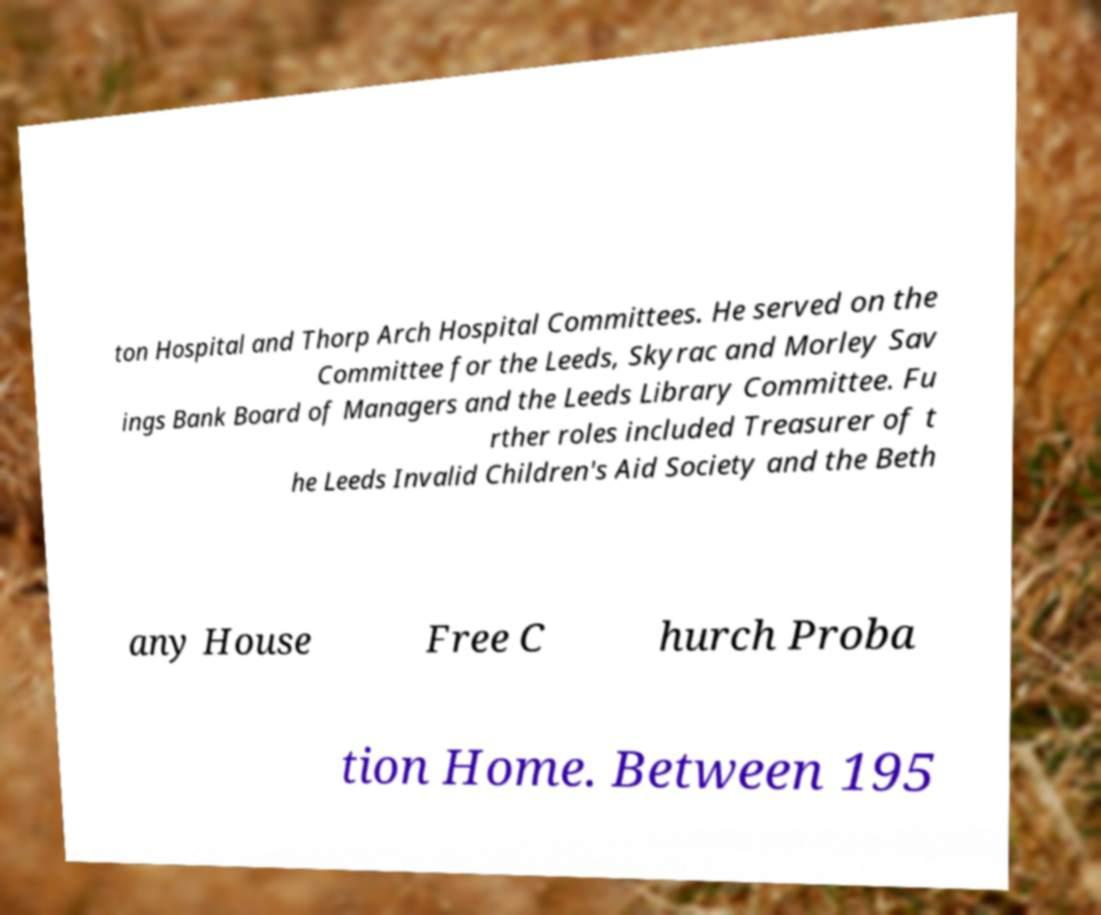Please identify and transcribe the text found in this image. ton Hospital and Thorp Arch Hospital Committees. He served on the Committee for the Leeds, Skyrac and Morley Sav ings Bank Board of Managers and the Leeds Library Committee. Fu rther roles included Treasurer of t he Leeds Invalid Children's Aid Society and the Beth any House Free C hurch Proba tion Home. Between 195 